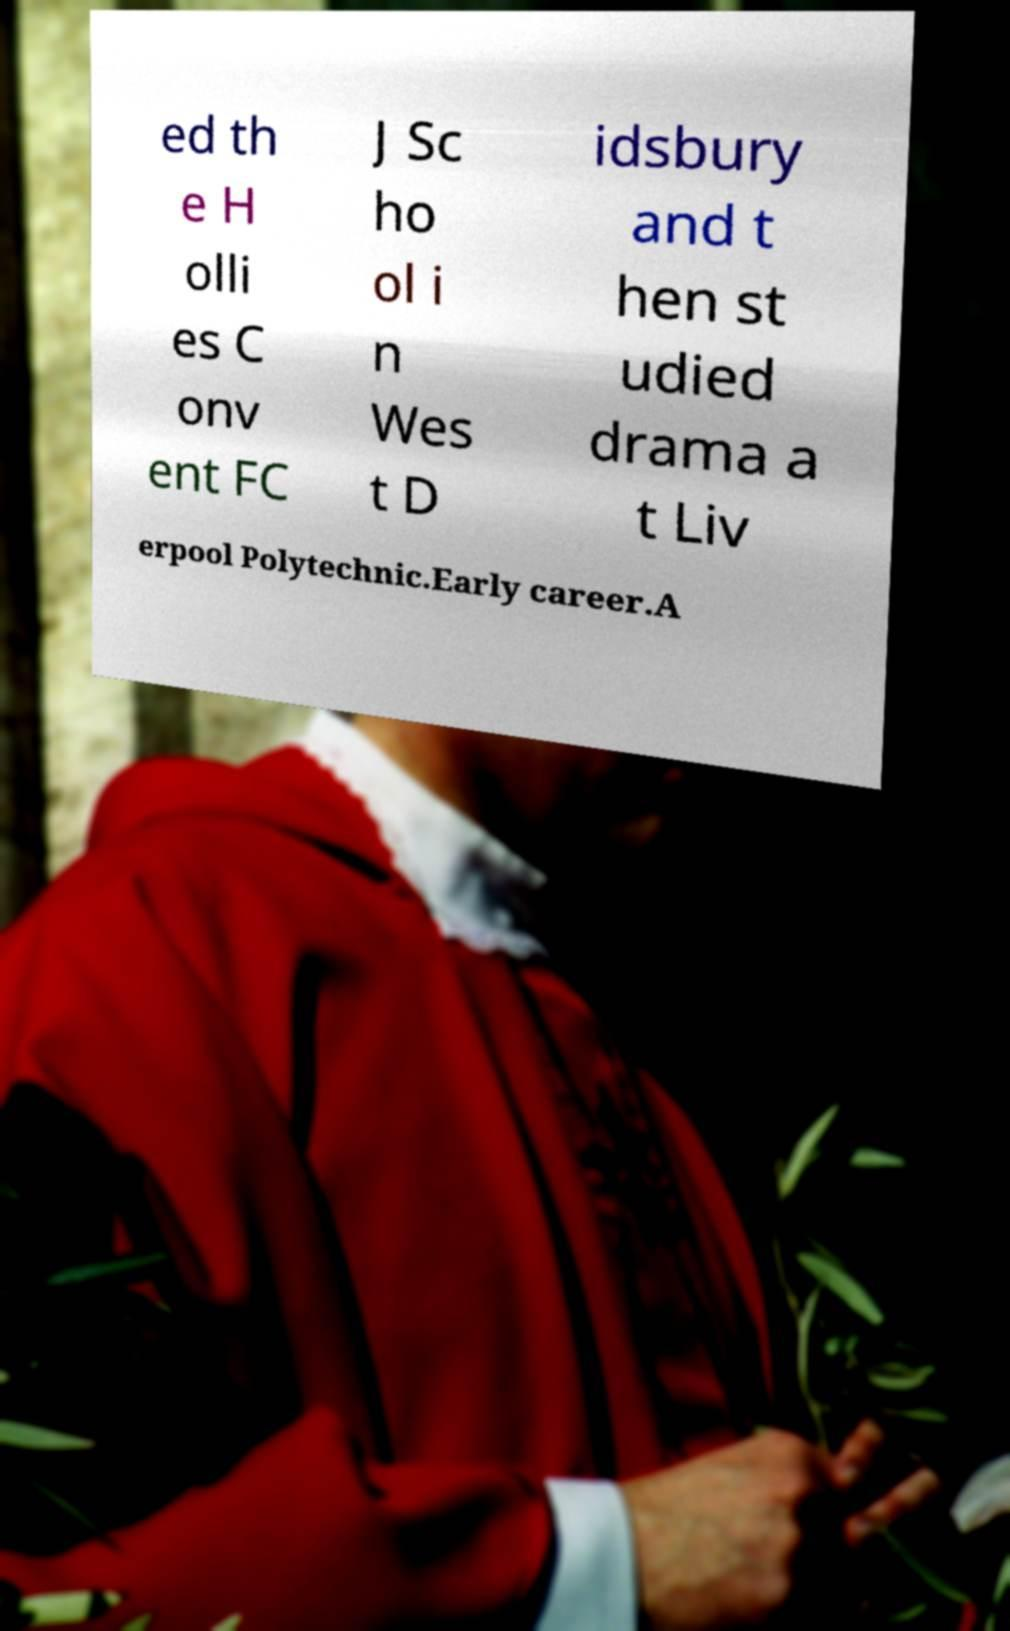There's text embedded in this image that I need extracted. Can you transcribe it verbatim? ed th e H olli es C onv ent FC J Sc ho ol i n Wes t D idsbury and t hen st udied drama a t Liv erpool Polytechnic.Early career.A 